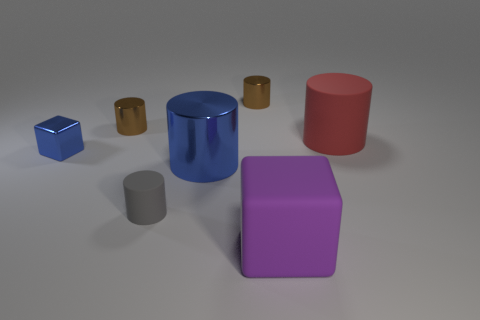The tiny rubber cylinder is what color?
Your response must be concise. Gray. What number of small objects are either gray rubber cylinders or brown cubes?
Keep it short and to the point. 1. There is a blue thing that is on the right side of the blue shiny block; is its size the same as the cylinder on the right side of the large purple thing?
Keep it short and to the point. Yes. What is the size of the other thing that is the same shape as the big purple object?
Provide a short and direct response. Small. Are there more tiny matte things behind the small blue thing than small blue metallic things that are in front of the red object?
Keep it short and to the point. No. The big thing that is both behind the large purple rubber object and in front of the small cube is made of what material?
Provide a succinct answer. Metal. There is another small thing that is the same shape as the purple rubber object; what color is it?
Your response must be concise. Blue. What is the size of the gray thing?
Keep it short and to the point. Small. There is a shiny thing that is behind the brown shiny cylinder that is on the left side of the gray cylinder; what is its color?
Keep it short and to the point. Brown. What number of rubber objects are in front of the tiny blue block and on the right side of the large purple cube?
Give a very brief answer. 0. 